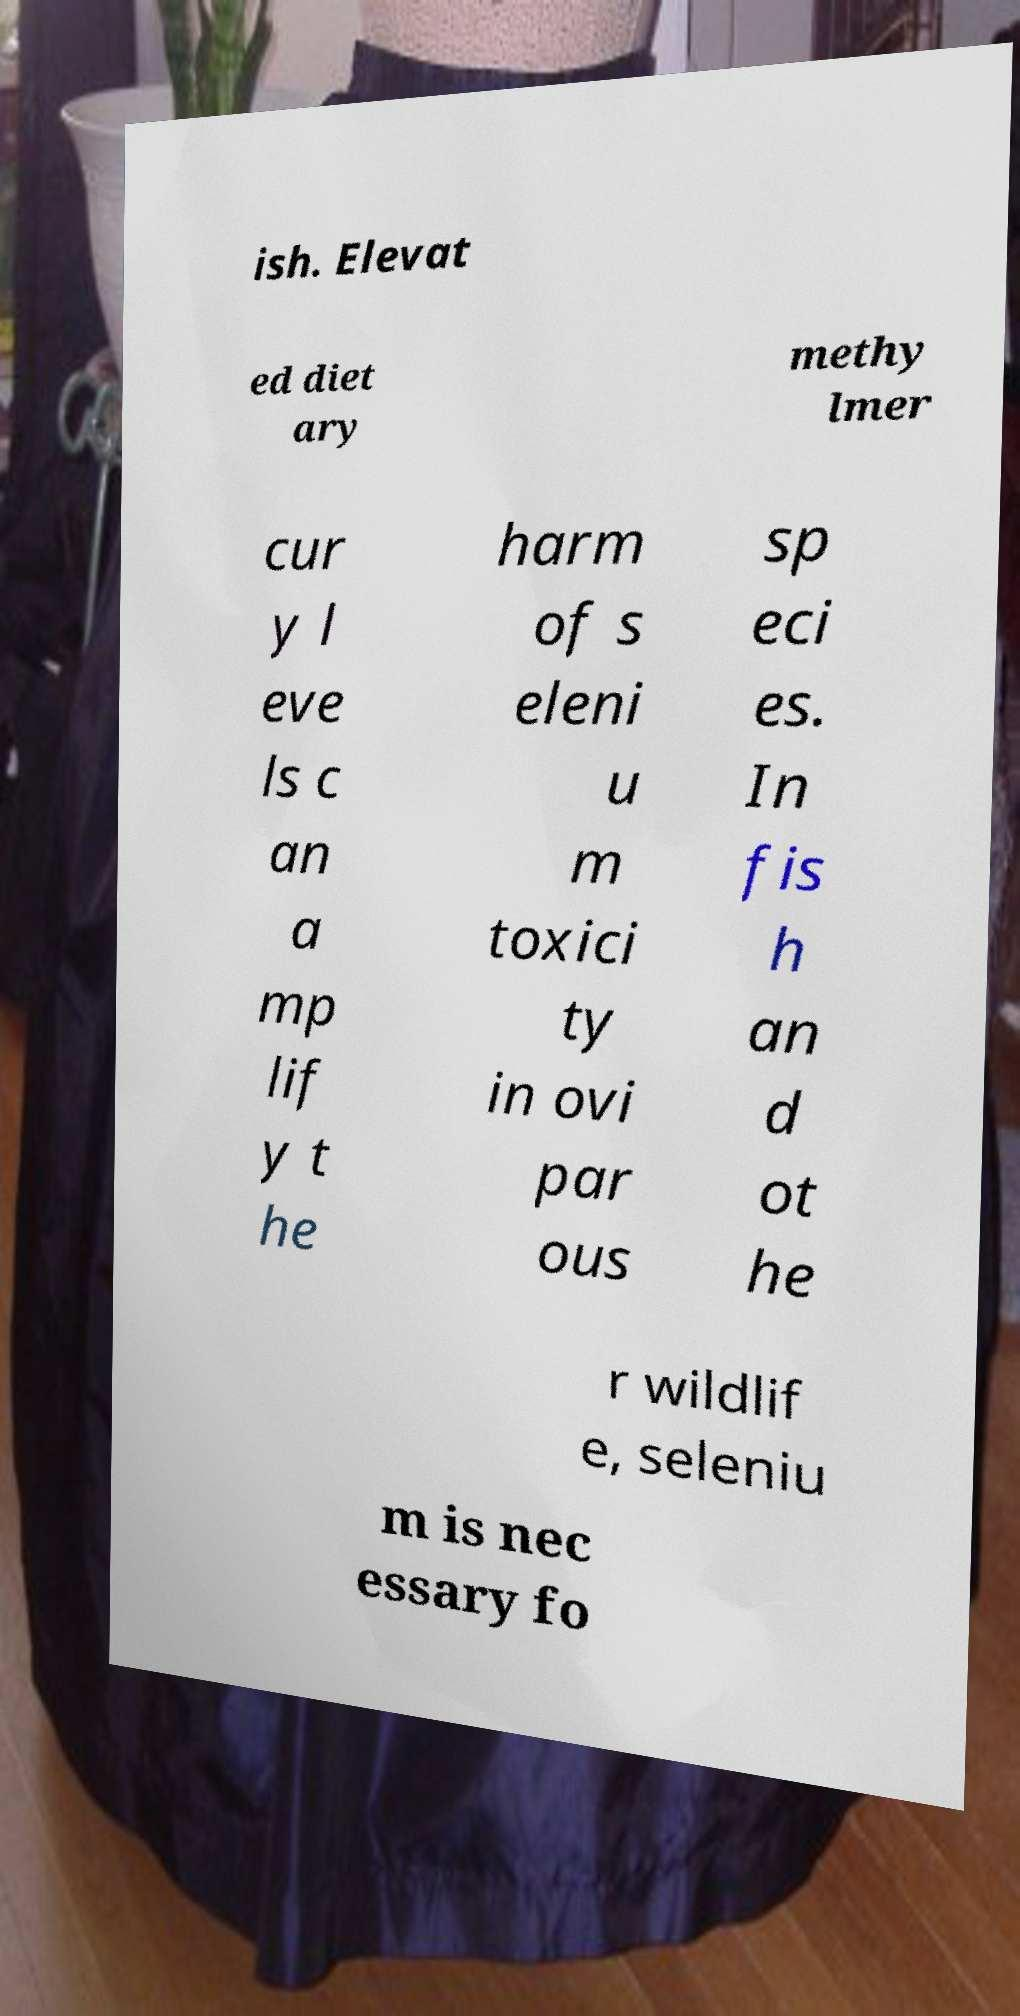Could you assist in decoding the text presented in this image and type it out clearly? ish. Elevat ed diet ary methy lmer cur y l eve ls c an a mp lif y t he harm of s eleni u m toxici ty in ovi par ous sp eci es. In fis h an d ot he r wildlif e, seleniu m is nec essary fo 